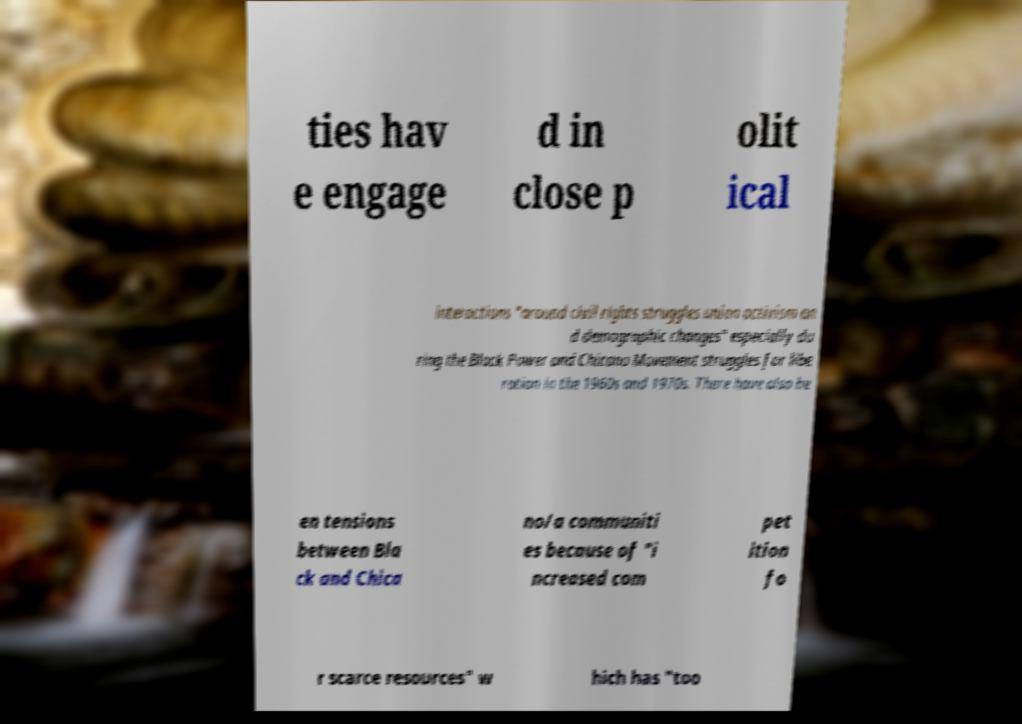Could you assist in decoding the text presented in this image and type it out clearly? ties hav e engage d in close p olit ical interactions "around civil rights struggles union activism an d demographic changes" especially du ring the Black Power and Chicano Movement struggles for libe ration in the 1960s and 1970s. There have also be en tensions between Bla ck and Chica no/a communiti es because of "i ncreased com pet ition fo r scarce resources" w hich has "too 